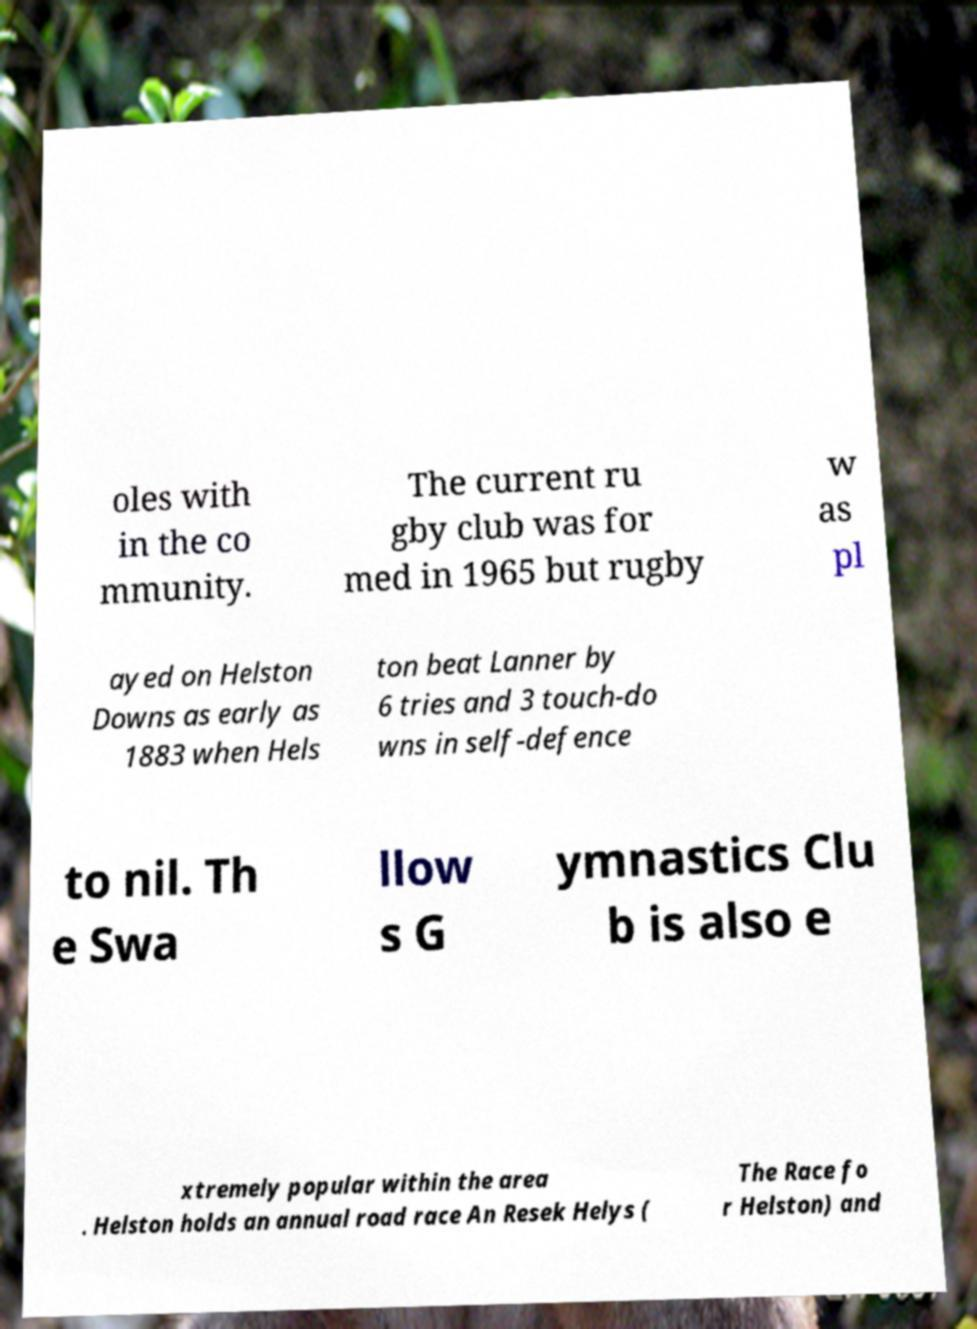There's text embedded in this image that I need extracted. Can you transcribe it verbatim? oles with in the co mmunity. The current ru gby club was for med in 1965 but rugby w as pl ayed on Helston Downs as early as 1883 when Hels ton beat Lanner by 6 tries and 3 touch-do wns in self-defence to nil. Th e Swa llow s G ymnastics Clu b is also e xtremely popular within the area . Helston holds an annual road race An Resek Helys ( The Race fo r Helston) and 